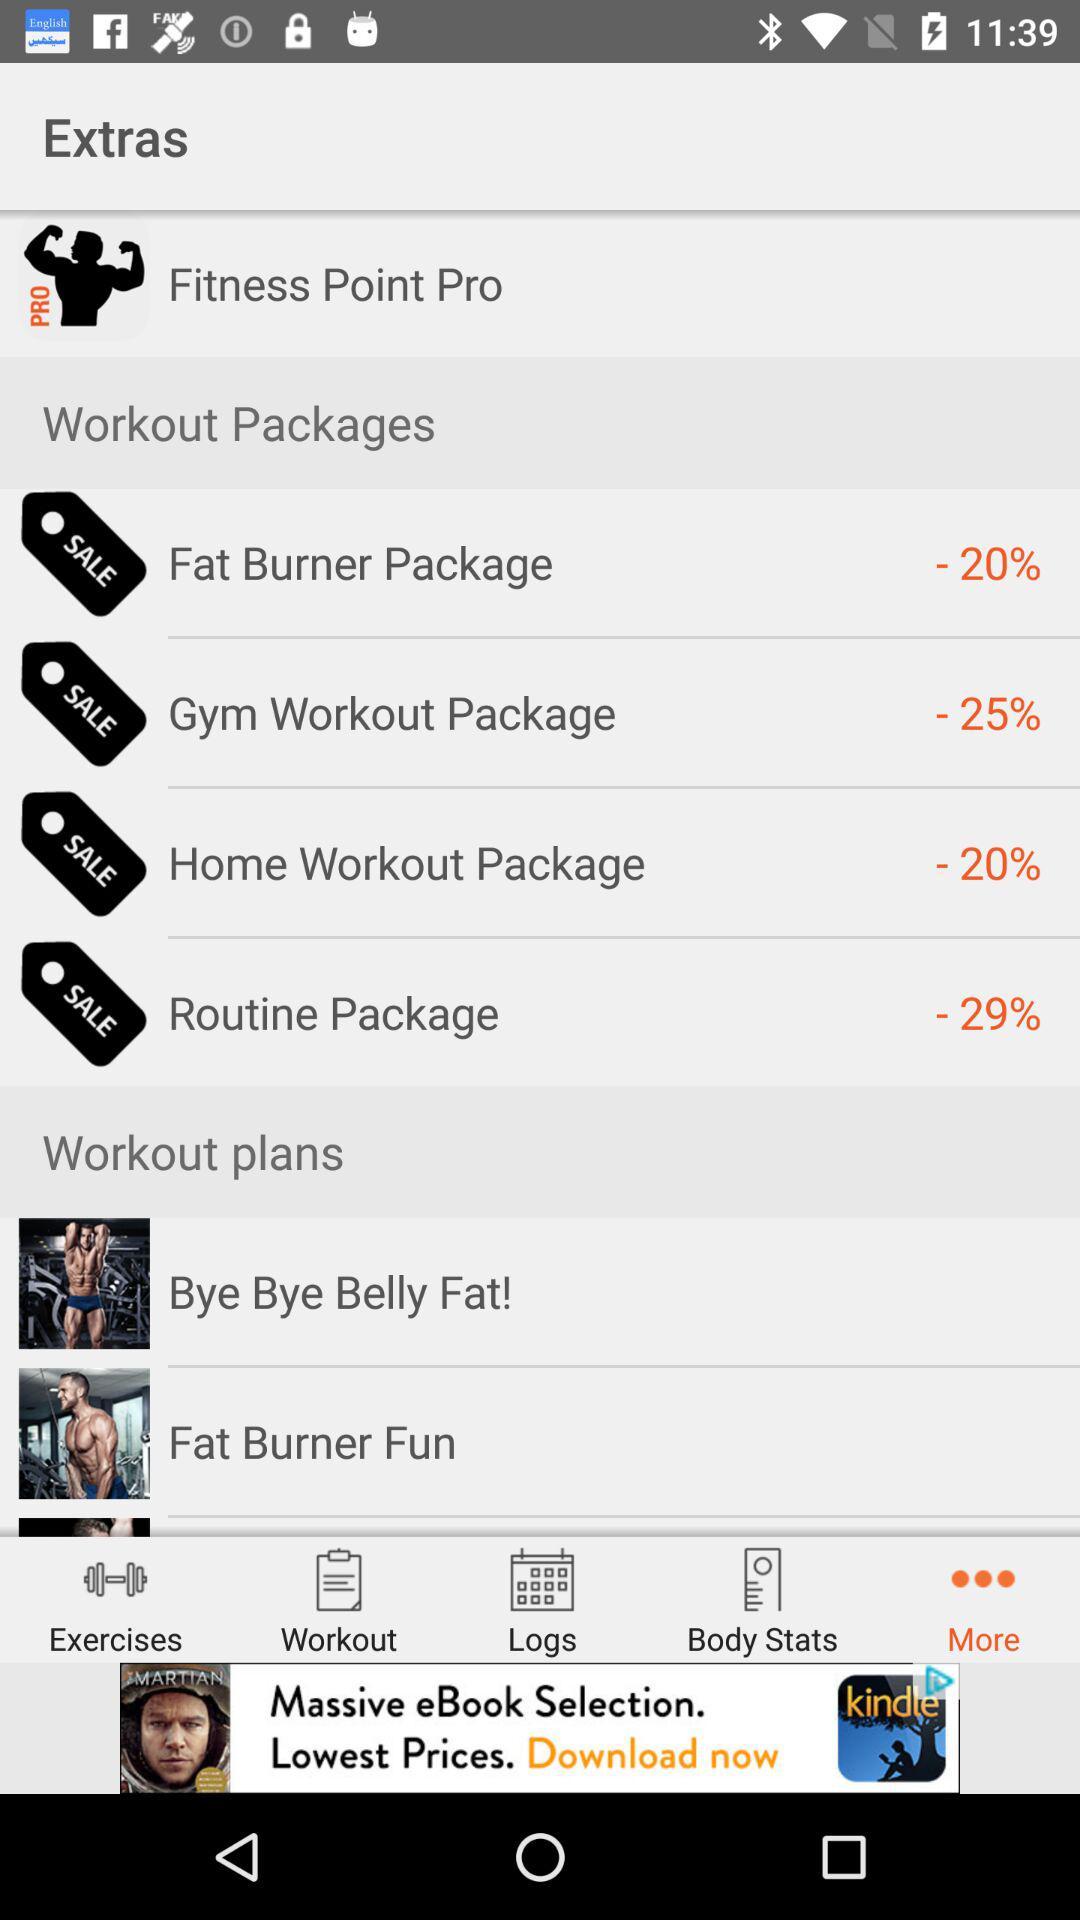Which tab is selected? The selected tab is "More". 